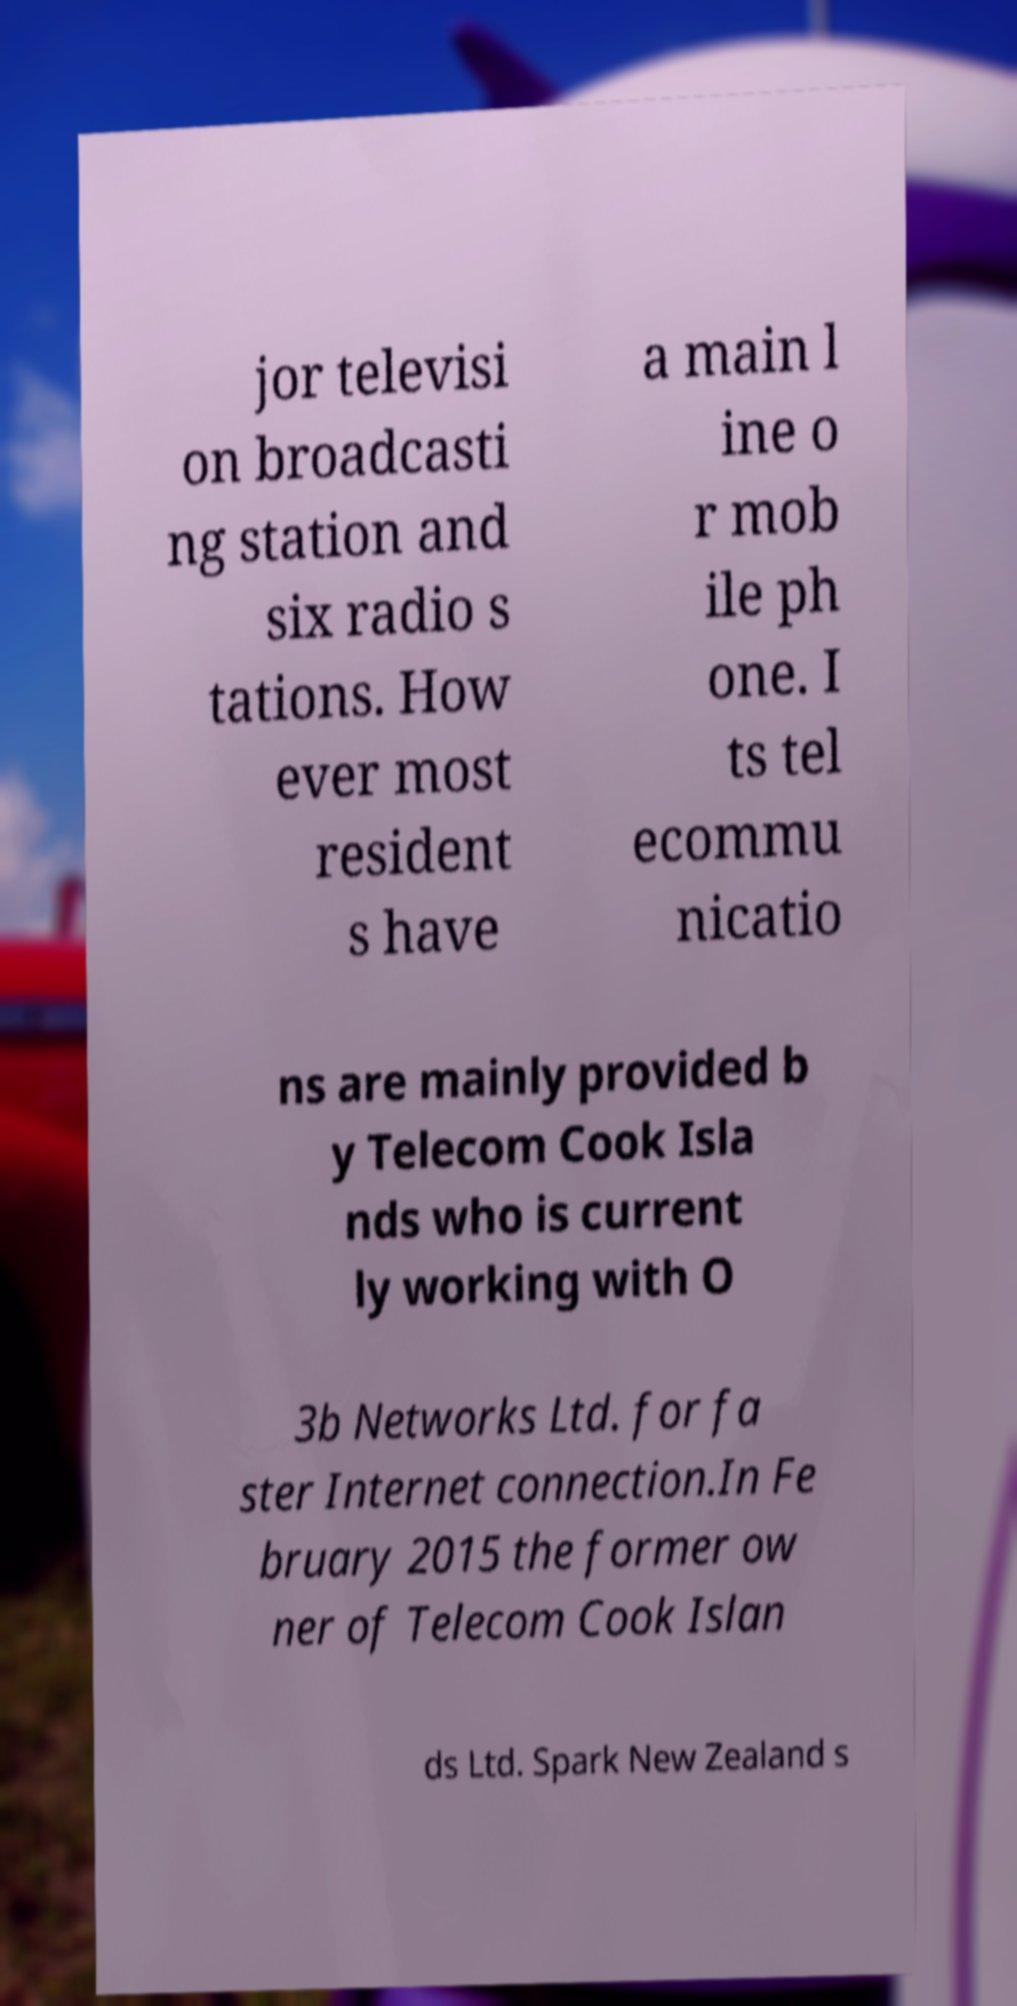Could you extract and type out the text from this image? jor televisi on broadcasti ng station and six radio s tations. How ever most resident s have a main l ine o r mob ile ph one. I ts tel ecommu nicatio ns are mainly provided b y Telecom Cook Isla nds who is current ly working with O 3b Networks Ltd. for fa ster Internet connection.In Fe bruary 2015 the former ow ner of Telecom Cook Islan ds Ltd. Spark New Zealand s 